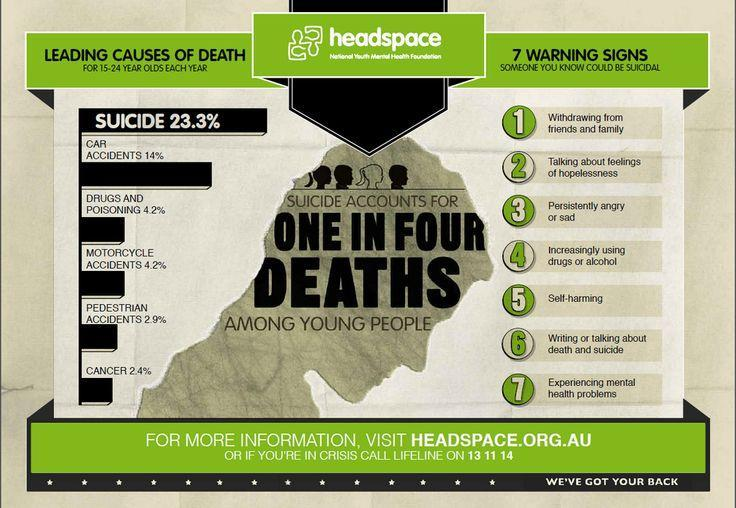What percentage of Suicides are caused by pedestrian accidents?
Answer the question with a short phrase. 2.9% What is fifth warning sign listed here? self-harming What percentage of Suicides are caused by Motorcycle accidents? 4.2% What percentage of Suicides are caused by car accidents? 14% 